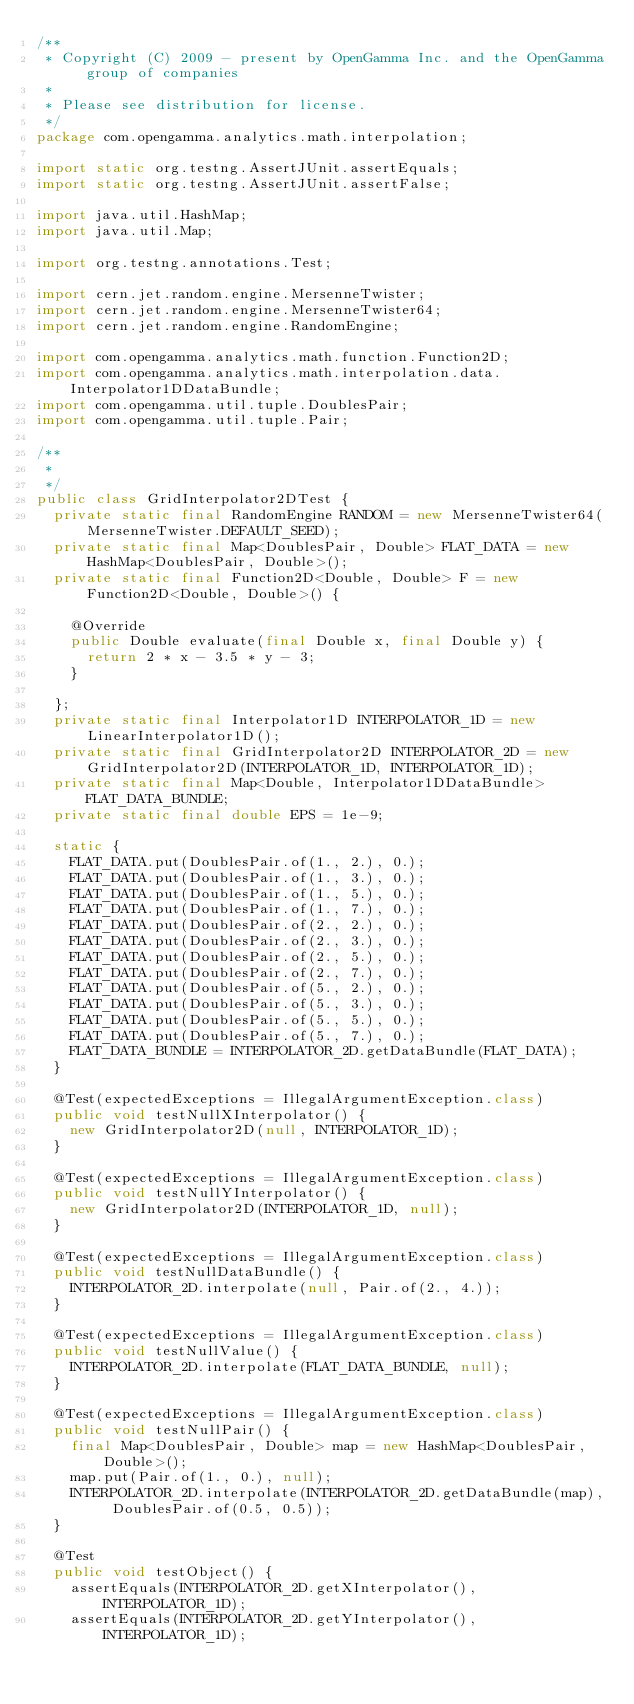<code> <loc_0><loc_0><loc_500><loc_500><_Java_>/**
 * Copyright (C) 2009 - present by OpenGamma Inc. and the OpenGamma group of companies
 * 
 * Please see distribution for license.
 */
package com.opengamma.analytics.math.interpolation;

import static org.testng.AssertJUnit.assertEquals;
import static org.testng.AssertJUnit.assertFalse;

import java.util.HashMap;
import java.util.Map;

import org.testng.annotations.Test;

import cern.jet.random.engine.MersenneTwister;
import cern.jet.random.engine.MersenneTwister64;
import cern.jet.random.engine.RandomEngine;

import com.opengamma.analytics.math.function.Function2D;
import com.opengamma.analytics.math.interpolation.data.Interpolator1DDataBundle;
import com.opengamma.util.tuple.DoublesPair;
import com.opengamma.util.tuple.Pair;

/**
 * 
 */
public class GridInterpolator2DTest {
  private static final RandomEngine RANDOM = new MersenneTwister64(MersenneTwister.DEFAULT_SEED);
  private static final Map<DoublesPair, Double> FLAT_DATA = new HashMap<DoublesPair, Double>();
  private static final Function2D<Double, Double> F = new Function2D<Double, Double>() {

    @Override
    public Double evaluate(final Double x, final Double y) {
      return 2 * x - 3.5 * y - 3;
    }

  };
  private static final Interpolator1D INTERPOLATOR_1D = new LinearInterpolator1D();
  private static final GridInterpolator2D INTERPOLATOR_2D = new GridInterpolator2D(INTERPOLATOR_1D, INTERPOLATOR_1D);
  private static final Map<Double, Interpolator1DDataBundle> FLAT_DATA_BUNDLE;
  private static final double EPS = 1e-9;

  static {
    FLAT_DATA.put(DoublesPair.of(1., 2.), 0.);
    FLAT_DATA.put(DoublesPair.of(1., 3.), 0.);
    FLAT_DATA.put(DoublesPair.of(1., 5.), 0.);
    FLAT_DATA.put(DoublesPair.of(1., 7.), 0.);
    FLAT_DATA.put(DoublesPair.of(2., 2.), 0.);
    FLAT_DATA.put(DoublesPair.of(2., 3.), 0.);
    FLAT_DATA.put(DoublesPair.of(2., 5.), 0.);
    FLAT_DATA.put(DoublesPair.of(2., 7.), 0.);
    FLAT_DATA.put(DoublesPair.of(5., 2.), 0.);
    FLAT_DATA.put(DoublesPair.of(5., 3.), 0.);
    FLAT_DATA.put(DoublesPair.of(5., 5.), 0.);
    FLAT_DATA.put(DoublesPair.of(5., 7.), 0.);
    FLAT_DATA_BUNDLE = INTERPOLATOR_2D.getDataBundle(FLAT_DATA);
  }

  @Test(expectedExceptions = IllegalArgumentException.class)
  public void testNullXInterpolator() {
    new GridInterpolator2D(null, INTERPOLATOR_1D);
  }

  @Test(expectedExceptions = IllegalArgumentException.class)
  public void testNullYInterpolator() {
    new GridInterpolator2D(INTERPOLATOR_1D, null);
  }

  @Test(expectedExceptions = IllegalArgumentException.class)
  public void testNullDataBundle() {
    INTERPOLATOR_2D.interpolate(null, Pair.of(2., 4.));
  }

  @Test(expectedExceptions = IllegalArgumentException.class)
  public void testNullValue() {
    INTERPOLATOR_2D.interpolate(FLAT_DATA_BUNDLE, null);
  }

  @Test(expectedExceptions = IllegalArgumentException.class)
  public void testNullPair() {
    final Map<DoublesPair, Double> map = new HashMap<DoublesPair, Double>();
    map.put(Pair.of(1., 0.), null);
    INTERPOLATOR_2D.interpolate(INTERPOLATOR_2D.getDataBundle(map), DoublesPair.of(0.5, 0.5));
  }

  @Test
  public void testObject() {
    assertEquals(INTERPOLATOR_2D.getXInterpolator(), INTERPOLATOR_1D);
    assertEquals(INTERPOLATOR_2D.getYInterpolator(), INTERPOLATOR_1D);</code> 